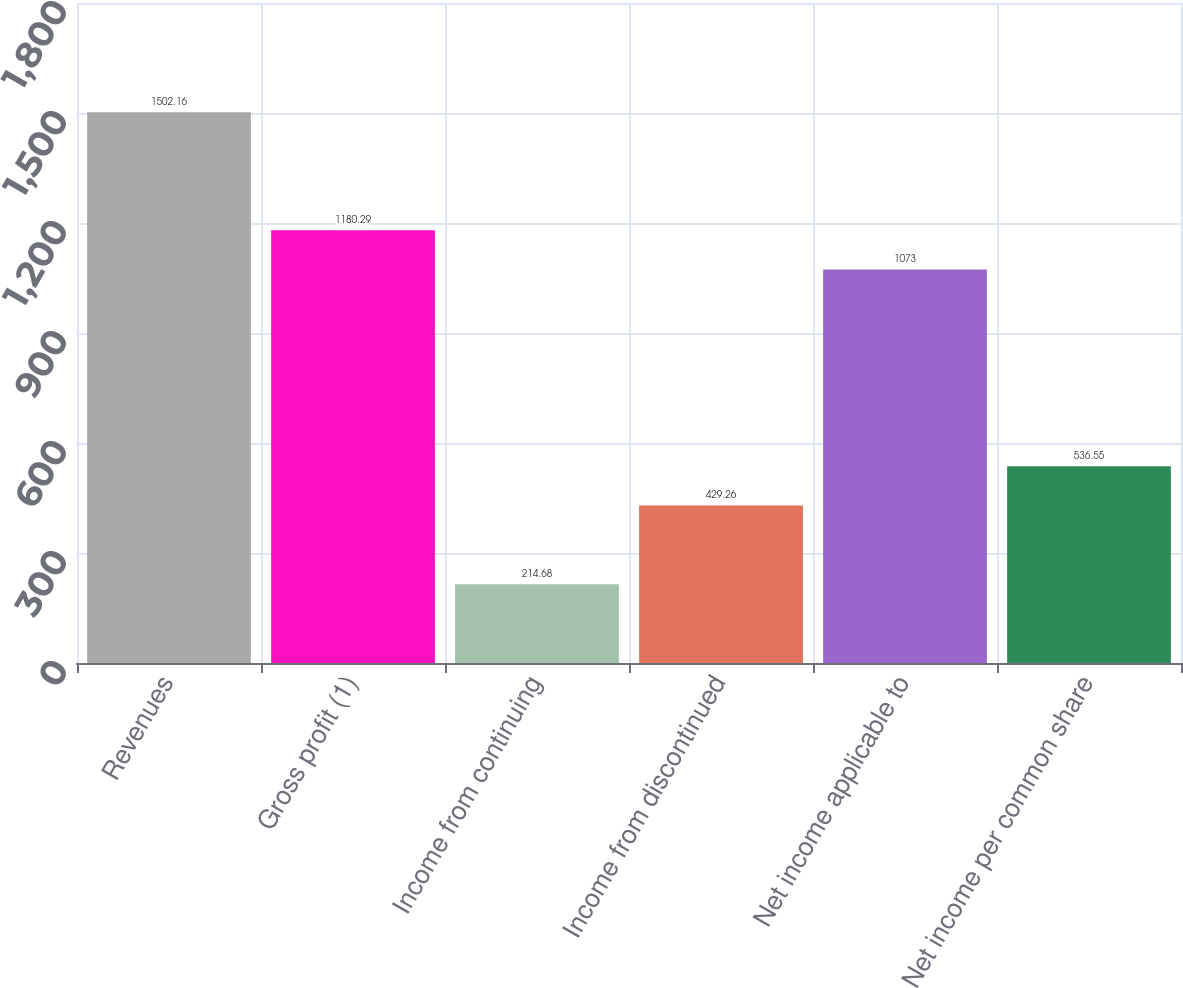Convert chart. <chart><loc_0><loc_0><loc_500><loc_500><bar_chart><fcel>Revenues<fcel>Gross profit (1)<fcel>Income from continuing<fcel>Income from discontinued<fcel>Net income applicable to<fcel>Net income per common share<nl><fcel>1502.16<fcel>1180.29<fcel>214.68<fcel>429.26<fcel>1073<fcel>536.55<nl></chart> 